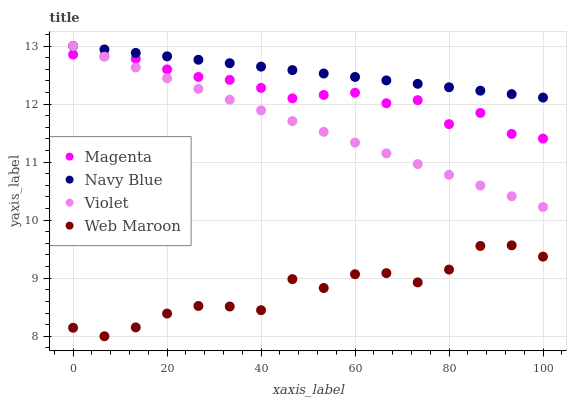Does Web Maroon have the minimum area under the curve?
Answer yes or no. Yes. Does Navy Blue have the maximum area under the curve?
Answer yes or no. Yes. Does Magenta have the minimum area under the curve?
Answer yes or no. No. Does Magenta have the maximum area under the curve?
Answer yes or no. No. Is Navy Blue the smoothest?
Answer yes or no. Yes. Is Web Maroon the roughest?
Answer yes or no. Yes. Is Magenta the smoothest?
Answer yes or no. No. Is Magenta the roughest?
Answer yes or no. No. Does Web Maroon have the lowest value?
Answer yes or no. Yes. Does Magenta have the lowest value?
Answer yes or no. No. Does Violet have the highest value?
Answer yes or no. Yes. Does Magenta have the highest value?
Answer yes or no. No. Is Web Maroon less than Navy Blue?
Answer yes or no. Yes. Is Navy Blue greater than Magenta?
Answer yes or no. Yes. Does Violet intersect Magenta?
Answer yes or no. Yes. Is Violet less than Magenta?
Answer yes or no. No. Is Violet greater than Magenta?
Answer yes or no. No. Does Web Maroon intersect Navy Blue?
Answer yes or no. No. 